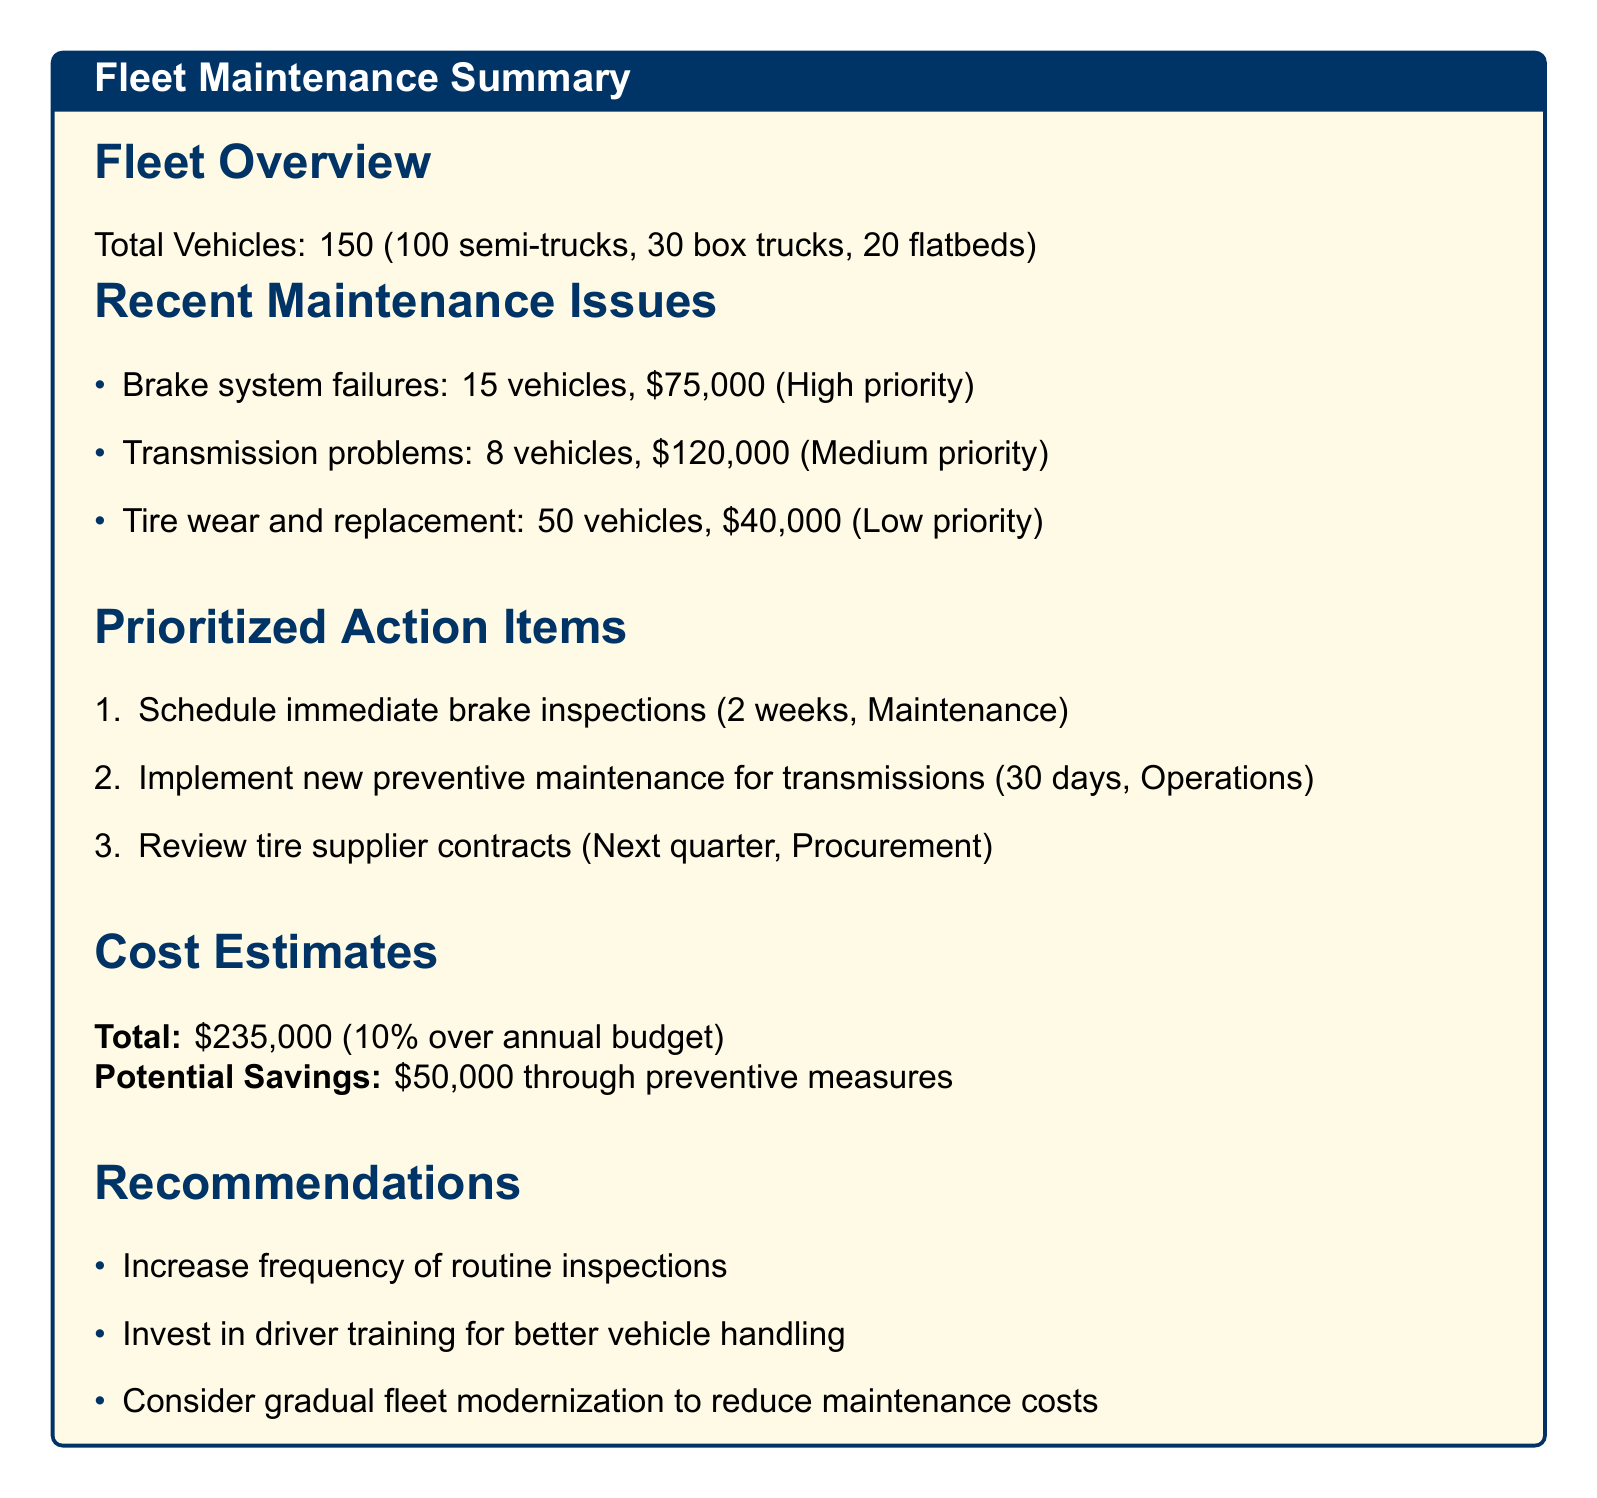What is the total number of vehicles in the fleet? The total number of vehicles is explicitly stated in the fleet overview section of the document.
Answer: 150 How many vehicles are affected by brake system failures? The number of vehicles affected by brake system failures is mentioned in the recent maintenance issues section.
Answer: 15 What is the estimated cost for transmission problems? The estimated cost for transmission problems is provided in the recent maintenance issues section.
Answer: $120,000 What is the timeline for scheduling brake inspections? The timeline for scheduling brake inspections is outlined in the prioritized action items section.
Answer: Within 2 weeks Which department is responsible for implementing the new preventive maintenance program? The responsible department for the preventive maintenance program is specified in the prioritized action items section.
Answer: Operations How much is the total estimated cost for all maintenance issues? The total estimated cost is summed up in the cost estimates section of the document.
Answer: $235,000 What percentage over the annual maintenance budget does the total cost represent? The budget impact is detailed in the cost estimates section, indicating the extent of the increase.
Answer: 10% What is one recommendation for improving vehicle maintenance? Recommendations for improving vehicle maintenance are listed in the recommendations section.
Answer: Increase frequency of routine inspections 